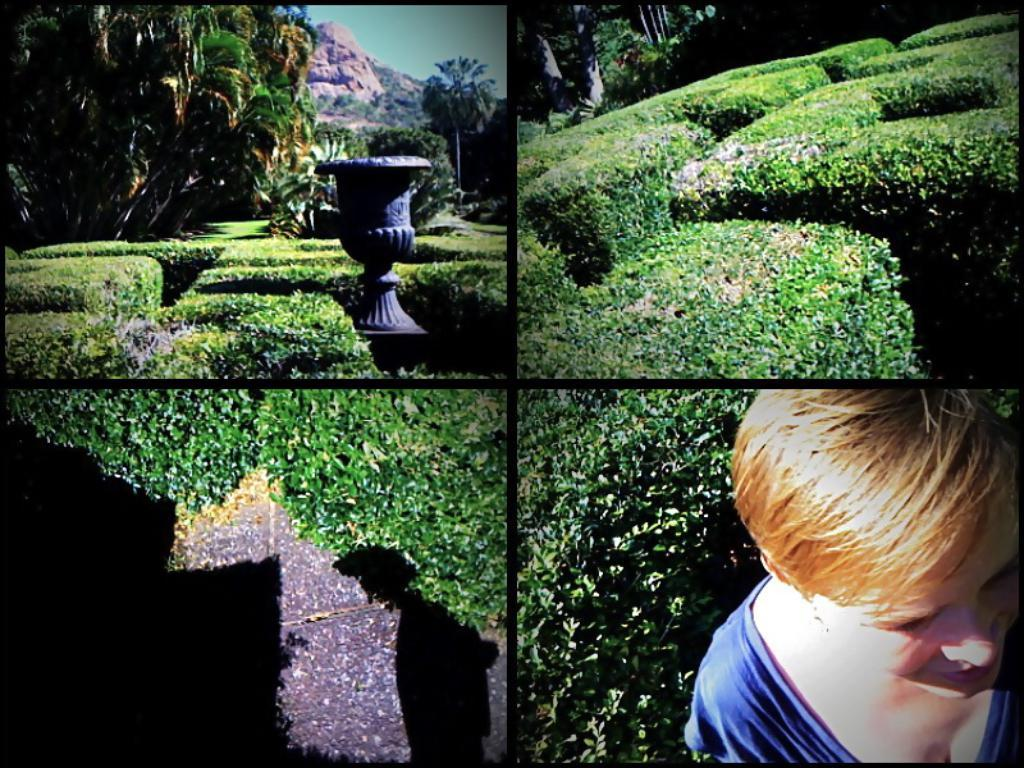What type of artwork is the image? The image is a collage. What natural elements can be seen in the image? There are plants, trees, and mountains in the image. Are there any human figures in the image? Yes, there is one person in the image. What type of structure is present in the image? There is a fountain in the image. How many cherries are on the trees in the image? There are no cherries present in the image; the trees are not specified as cherry trees. What stage of development is the person in the image? The image does not provide information about the person's developmental stage. 